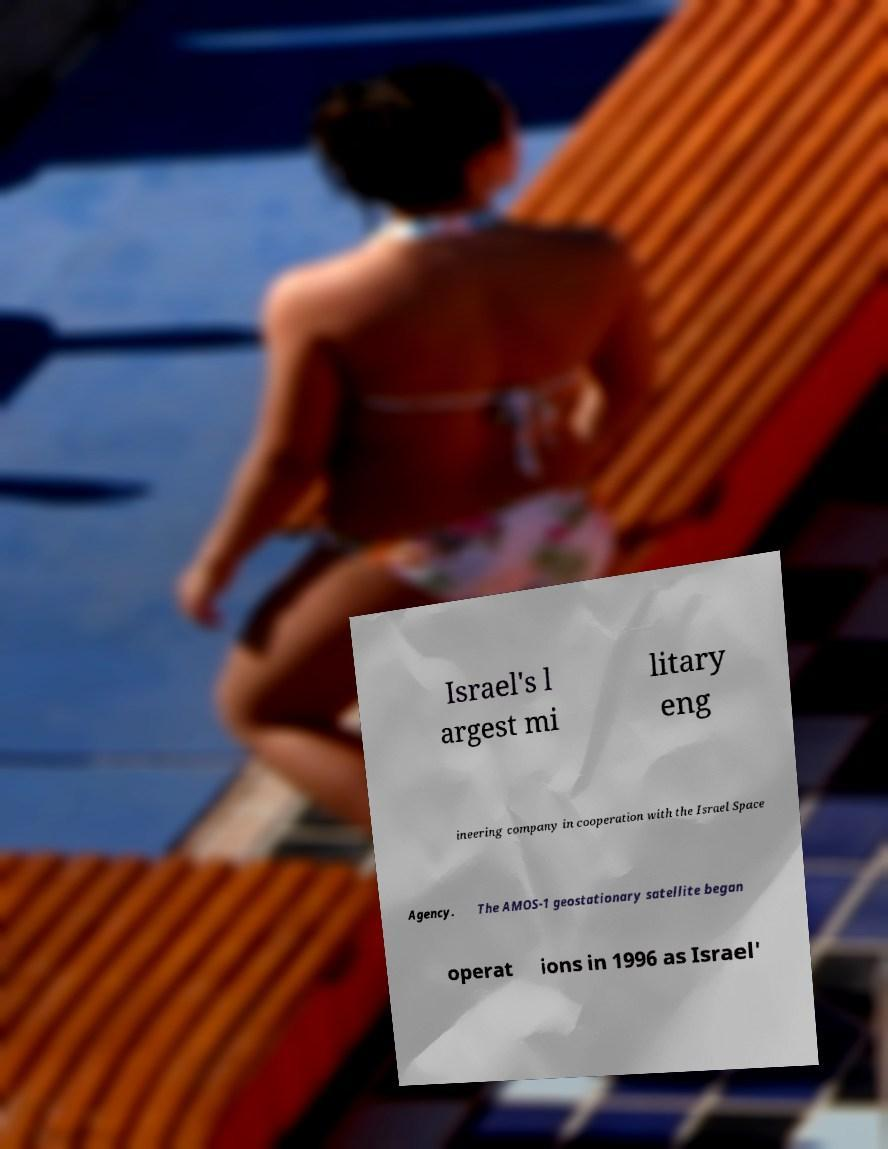What messages or text are displayed in this image? I need them in a readable, typed format. Israel's l argest mi litary eng ineering company in cooperation with the Israel Space Agency. The AMOS-1 geostationary satellite began operat ions in 1996 as Israel' 